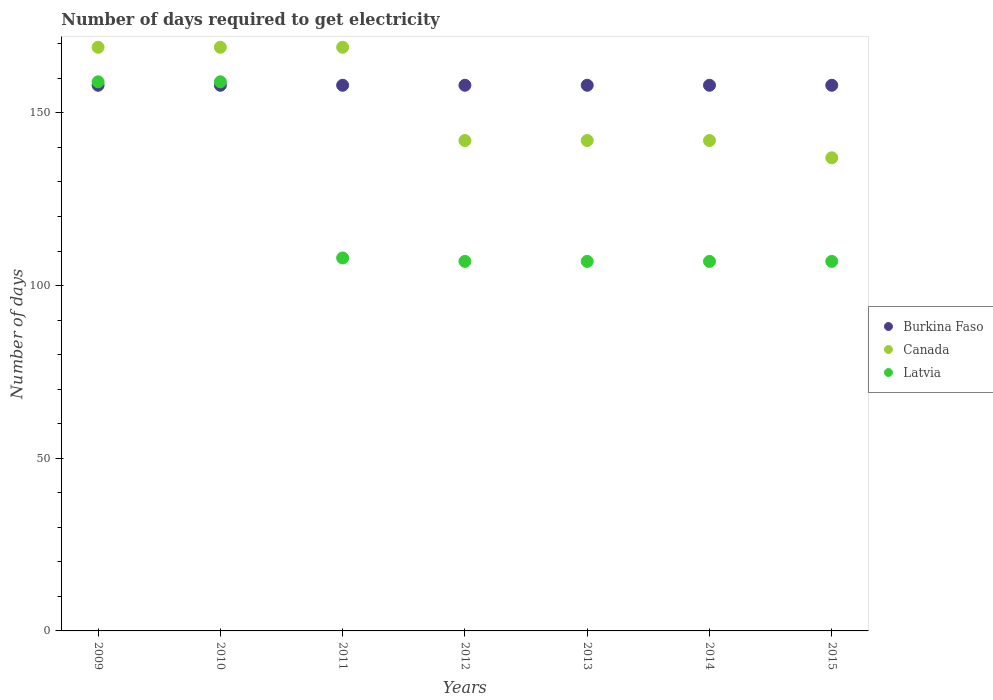How many different coloured dotlines are there?
Offer a terse response. 3. Is the number of dotlines equal to the number of legend labels?
Offer a terse response. Yes. What is the number of days required to get electricity in in Canada in 2013?
Your answer should be very brief. 142. Across all years, what is the maximum number of days required to get electricity in in Canada?
Your answer should be compact. 169. Across all years, what is the minimum number of days required to get electricity in in Burkina Faso?
Offer a terse response. 158. In which year was the number of days required to get electricity in in Burkina Faso maximum?
Give a very brief answer. 2009. In which year was the number of days required to get electricity in in Canada minimum?
Keep it short and to the point. 2015. What is the total number of days required to get electricity in in Burkina Faso in the graph?
Offer a very short reply. 1106. What is the difference between the number of days required to get electricity in in Canada in 2010 and that in 2015?
Offer a very short reply. 32. What is the difference between the number of days required to get electricity in in Burkina Faso in 2009 and the number of days required to get electricity in in Latvia in 2012?
Make the answer very short. 51. What is the average number of days required to get electricity in in Burkina Faso per year?
Your answer should be very brief. 158. In the year 2013, what is the difference between the number of days required to get electricity in in Latvia and number of days required to get electricity in in Canada?
Your answer should be very brief. -35. In how many years, is the number of days required to get electricity in in Burkina Faso greater than 100 days?
Make the answer very short. 7. Is the difference between the number of days required to get electricity in in Latvia in 2011 and 2015 greater than the difference between the number of days required to get electricity in in Canada in 2011 and 2015?
Ensure brevity in your answer.  No. What is the difference between the highest and the lowest number of days required to get electricity in in Burkina Faso?
Provide a succinct answer. 0. In how many years, is the number of days required to get electricity in in Canada greater than the average number of days required to get electricity in in Canada taken over all years?
Offer a terse response. 3. Is the sum of the number of days required to get electricity in in Burkina Faso in 2009 and 2013 greater than the maximum number of days required to get electricity in in Canada across all years?
Keep it short and to the point. Yes. Is the number of days required to get electricity in in Burkina Faso strictly less than the number of days required to get electricity in in Latvia over the years?
Your answer should be compact. No. How many dotlines are there?
Keep it short and to the point. 3. What is the difference between two consecutive major ticks on the Y-axis?
Make the answer very short. 50. Does the graph contain any zero values?
Offer a terse response. No. What is the title of the graph?
Ensure brevity in your answer.  Number of days required to get electricity. What is the label or title of the Y-axis?
Make the answer very short. Number of days. What is the Number of days of Burkina Faso in 2009?
Your response must be concise. 158. What is the Number of days of Canada in 2009?
Give a very brief answer. 169. What is the Number of days of Latvia in 2009?
Ensure brevity in your answer.  159. What is the Number of days of Burkina Faso in 2010?
Offer a terse response. 158. What is the Number of days of Canada in 2010?
Provide a succinct answer. 169. What is the Number of days of Latvia in 2010?
Your response must be concise. 159. What is the Number of days in Burkina Faso in 2011?
Ensure brevity in your answer.  158. What is the Number of days of Canada in 2011?
Provide a short and direct response. 169. What is the Number of days in Latvia in 2011?
Your answer should be very brief. 108. What is the Number of days of Burkina Faso in 2012?
Give a very brief answer. 158. What is the Number of days in Canada in 2012?
Your answer should be compact. 142. What is the Number of days of Latvia in 2012?
Your answer should be compact. 107. What is the Number of days in Burkina Faso in 2013?
Provide a succinct answer. 158. What is the Number of days in Canada in 2013?
Offer a very short reply. 142. What is the Number of days in Latvia in 2013?
Offer a very short reply. 107. What is the Number of days of Burkina Faso in 2014?
Your answer should be very brief. 158. What is the Number of days in Canada in 2014?
Ensure brevity in your answer.  142. What is the Number of days in Latvia in 2014?
Give a very brief answer. 107. What is the Number of days in Burkina Faso in 2015?
Your answer should be very brief. 158. What is the Number of days in Canada in 2015?
Give a very brief answer. 137. What is the Number of days of Latvia in 2015?
Offer a terse response. 107. Across all years, what is the maximum Number of days of Burkina Faso?
Give a very brief answer. 158. Across all years, what is the maximum Number of days of Canada?
Provide a short and direct response. 169. Across all years, what is the maximum Number of days in Latvia?
Make the answer very short. 159. Across all years, what is the minimum Number of days in Burkina Faso?
Your response must be concise. 158. Across all years, what is the minimum Number of days of Canada?
Give a very brief answer. 137. Across all years, what is the minimum Number of days of Latvia?
Provide a short and direct response. 107. What is the total Number of days of Burkina Faso in the graph?
Offer a terse response. 1106. What is the total Number of days of Canada in the graph?
Keep it short and to the point. 1070. What is the total Number of days of Latvia in the graph?
Offer a very short reply. 854. What is the difference between the Number of days in Burkina Faso in 2009 and that in 2010?
Your response must be concise. 0. What is the difference between the Number of days in Latvia in 2009 and that in 2010?
Keep it short and to the point. 0. What is the difference between the Number of days of Burkina Faso in 2009 and that in 2011?
Give a very brief answer. 0. What is the difference between the Number of days of Burkina Faso in 2009 and that in 2013?
Ensure brevity in your answer.  0. What is the difference between the Number of days of Latvia in 2009 and that in 2013?
Provide a succinct answer. 52. What is the difference between the Number of days in Burkina Faso in 2009 and that in 2014?
Give a very brief answer. 0. What is the difference between the Number of days of Burkina Faso in 2009 and that in 2015?
Your answer should be compact. 0. What is the difference between the Number of days of Canada in 2009 and that in 2015?
Offer a very short reply. 32. What is the difference between the Number of days of Burkina Faso in 2010 and that in 2011?
Your answer should be very brief. 0. What is the difference between the Number of days of Canada in 2010 and that in 2011?
Make the answer very short. 0. What is the difference between the Number of days in Burkina Faso in 2010 and that in 2012?
Provide a short and direct response. 0. What is the difference between the Number of days in Canada in 2010 and that in 2012?
Your response must be concise. 27. What is the difference between the Number of days of Latvia in 2010 and that in 2012?
Offer a terse response. 52. What is the difference between the Number of days in Burkina Faso in 2010 and that in 2013?
Your response must be concise. 0. What is the difference between the Number of days in Canada in 2010 and that in 2013?
Offer a terse response. 27. What is the difference between the Number of days of Burkina Faso in 2010 and that in 2014?
Offer a very short reply. 0. What is the difference between the Number of days of Canada in 2010 and that in 2014?
Keep it short and to the point. 27. What is the difference between the Number of days of Burkina Faso in 2010 and that in 2015?
Keep it short and to the point. 0. What is the difference between the Number of days of Canada in 2010 and that in 2015?
Give a very brief answer. 32. What is the difference between the Number of days in Canada in 2011 and that in 2012?
Your response must be concise. 27. What is the difference between the Number of days in Canada in 2011 and that in 2013?
Your answer should be compact. 27. What is the difference between the Number of days of Latvia in 2011 and that in 2013?
Provide a succinct answer. 1. What is the difference between the Number of days of Burkina Faso in 2011 and that in 2014?
Give a very brief answer. 0. What is the difference between the Number of days in Canada in 2011 and that in 2014?
Your response must be concise. 27. What is the difference between the Number of days in Latvia in 2011 and that in 2014?
Offer a terse response. 1. What is the difference between the Number of days in Burkina Faso in 2011 and that in 2015?
Offer a terse response. 0. What is the difference between the Number of days in Canada in 2011 and that in 2015?
Keep it short and to the point. 32. What is the difference between the Number of days in Burkina Faso in 2012 and that in 2013?
Ensure brevity in your answer.  0. What is the difference between the Number of days in Burkina Faso in 2012 and that in 2014?
Provide a succinct answer. 0. What is the difference between the Number of days in Latvia in 2012 and that in 2014?
Give a very brief answer. 0. What is the difference between the Number of days of Burkina Faso in 2012 and that in 2015?
Your answer should be compact. 0. What is the difference between the Number of days of Canada in 2012 and that in 2015?
Your answer should be very brief. 5. What is the difference between the Number of days of Burkina Faso in 2013 and that in 2014?
Give a very brief answer. 0. What is the difference between the Number of days of Canada in 2013 and that in 2014?
Provide a succinct answer. 0. What is the difference between the Number of days in Canada in 2013 and that in 2015?
Provide a short and direct response. 5. What is the difference between the Number of days of Latvia in 2013 and that in 2015?
Offer a terse response. 0. What is the difference between the Number of days of Burkina Faso in 2009 and the Number of days of Canada in 2010?
Provide a short and direct response. -11. What is the difference between the Number of days of Burkina Faso in 2009 and the Number of days of Canada in 2011?
Offer a terse response. -11. What is the difference between the Number of days in Burkina Faso in 2009 and the Number of days in Latvia in 2012?
Ensure brevity in your answer.  51. What is the difference between the Number of days of Burkina Faso in 2009 and the Number of days of Canada in 2013?
Your answer should be very brief. 16. What is the difference between the Number of days in Burkina Faso in 2009 and the Number of days in Latvia in 2013?
Keep it short and to the point. 51. What is the difference between the Number of days of Canada in 2009 and the Number of days of Latvia in 2015?
Provide a succinct answer. 62. What is the difference between the Number of days of Burkina Faso in 2010 and the Number of days of Latvia in 2011?
Provide a short and direct response. 50. What is the difference between the Number of days of Canada in 2010 and the Number of days of Latvia in 2011?
Your answer should be compact. 61. What is the difference between the Number of days of Burkina Faso in 2010 and the Number of days of Latvia in 2012?
Provide a short and direct response. 51. What is the difference between the Number of days of Canada in 2010 and the Number of days of Latvia in 2012?
Provide a succinct answer. 62. What is the difference between the Number of days of Burkina Faso in 2010 and the Number of days of Canada in 2013?
Ensure brevity in your answer.  16. What is the difference between the Number of days in Canada in 2010 and the Number of days in Latvia in 2013?
Keep it short and to the point. 62. What is the difference between the Number of days in Burkina Faso in 2010 and the Number of days in Canada in 2014?
Offer a terse response. 16. What is the difference between the Number of days in Burkina Faso in 2010 and the Number of days in Canada in 2015?
Provide a short and direct response. 21. What is the difference between the Number of days of Burkina Faso in 2011 and the Number of days of Latvia in 2012?
Make the answer very short. 51. What is the difference between the Number of days in Canada in 2011 and the Number of days in Latvia in 2012?
Offer a terse response. 62. What is the difference between the Number of days in Canada in 2011 and the Number of days in Latvia in 2014?
Provide a short and direct response. 62. What is the difference between the Number of days in Burkina Faso in 2011 and the Number of days in Canada in 2015?
Give a very brief answer. 21. What is the difference between the Number of days in Canada in 2012 and the Number of days in Latvia in 2013?
Give a very brief answer. 35. What is the difference between the Number of days of Burkina Faso in 2012 and the Number of days of Canada in 2014?
Your answer should be compact. 16. What is the difference between the Number of days in Burkina Faso in 2012 and the Number of days in Canada in 2015?
Make the answer very short. 21. What is the difference between the Number of days of Burkina Faso in 2012 and the Number of days of Latvia in 2015?
Your response must be concise. 51. What is the difference between the Number of days of Burkina Faso in 2013 and the Number of days of Canada in 2014?
Your answer should be very brief. 16. What is the difference between the Number of days in Burkina Faso in 2013 and the Number of days in Canada in 2015?
Your answer should be very brief. 21. What is the difference between the Number of days in Burkina Faso in 2013 and the Number of days in Latvia in 2015?
Ensure brevity in your answer.  51. What is the difference between the Number of days in Canada in 2013 and the Number of days in Latvia in 2015?
Provide a short and direct response. 35. What is the difference between the Number of days of Burkina Faso in 2014 and the Number of days of Latvia in 2015?
Your answer should be compact. 51. What is the difference between the Number of days of Canada in 2014 and the Number of days of Latvia in 2015?
Your answer should be compact. 35. What is the average Number of days in Burkina Faso per year?
Your response must be concise. 158. What is the average Number of days of Canada per year?
Offer a very short reply. 152.86. What is the average Number of days of Latvia per year?
Make the answer very short. 122. In the year 2010, what is the difference between the Number of days of Burkina Faso and Number of days of Latvia?
Your response must be concise. -1. In the year 2010, what is the difference between the Number of days in Canada and Number of days in Latvia?
Give a very brief answer. 10. In the year 2011, what is the difference between the Number of days of Canada and Number of days of Latvia?
Provide a succinct answer. 61. In the year 2013, what is the difference between the Number of days in Burkina Faso and Number of days in Canada?
Provide a succinct answer. 16. In the year 2013, what is the difference between the Number of days of Burkina Faso and Number of days of Latvia?
Your answer should be very brief. 51. In the year 2013, what is the difference between the Number of days in Canada and Number of days in Latvia?
Keep it short and to the point. 35. In the year 2014, what is the difference between the Number of days in Burkina Faso and Number of days in Canada?
Keep it short and to the point. 16. What is the ratio of the Number of days of Burkina Faso in 2009 to that in 2010?
Offer a terse response. 1. What is the ratio of the Number of days in Latvia in 2009 to that in 2010?
Provide a short and direct response. 1. What is the ratio of the Number of days of Latvia in 2009 to that in 2011?
Your answer should be very brief. 1.47. What is the ratio of the Number of days in Burkina Faso in 2009 to that in 2012?
Make the answer very short. 1. What is the ratio of the Number of days in Canada in 2009 to that in 2012?
Your answer should be compact. 1.19. What is the ratio of the Number of days of Latvia in 2009 to that in 2012?
Your response must be concise. 1.49. What is the ratio of the Number of days of Burkina Faso in 2009 to that in 2013?
Offer a very short reply. 1. What is the ratio of the Number of days in Canada in 2009 to that in 2013?
Keep it short and to the point. 1.19. What is the ratio of the Number of days in Latvia in 2009 to that in 2013?
Ensure brevity in your answer.  1.49. What is the ratio of the Number of days in Canada in 2009 to that in 2014?
Your answer should be very brief. 1.19. What is the ratio of the Number of days in Latvia in 2009 to that in 2014?
Give a very brief answer. 1.49. What is the ratio of the Number of days in Burkina Faso in 2009 to that in 2015?
Your answer should be compact. 1. What is the ratio of the Number of days in Canada in 2009 to that in 2015?
Offer a terse response. 1.23. What is the ratio of the Number of days in Latvia in 2009 to that in 2015?
Offer a very short reply. 1.49. What is the ratio of the Number of days in Burkina Faso in 2010 to that in 2011?
Offer a very short reply. 1. What is the ratio of the Number of days of Latvia in 2010 to that in 2011?
Provide a succinct answer. 1.47. What is the ratio of the Number of days of Burkina Faso in 2010 to that in 2012?
Your answer should be compact. 1. What is the ratio of the Number of days of Canada in 2010 to that in 2012?
Ensure brevity in your answer.  1.19. What is the ratio of the Number of days in Latvia in 2010 to that in 2012?
Offer a terse response. 1.49. What is the ratio of the Number of days in Canada in 2010 to that in 2013?
Ensure brevity in your answer.  1.19. What is the ratio of the Number of days in Latvia in 2010 to that in 2013?
Give a very brief answer. 1.49. What is the ratio of the Number of days of Burkina Faso in 2010 to that in 2014?
Offer a very short reply. 1. What is the ratio of the Number of days in Canada in 2010 to that in 2014?
Ensure brevity in your answer.  1.19. What is the ratio of the Number of days in Latvia in 2010 to that in 2014?
Offer a terse response. 1.49. What is the ratio of the Number of days of Burkina Faso in 2010 to that in 2015?
Your answer should be very brief. 1. What is the ratio of the Number of days in Canada in 2010 to that in 2015?
Offer a terse response. 1.23. What is the ratio of the Number of days of Latvia in 2010 to that in 2015?
Offer a very short reply. 1.49. What is the ratio of the Number of days of Canada in 2011 to that in 2012?
Make the answer very short. 1.19. What is the ratio of the Number of days of Latvia in 2011 to that in 2012?
Make the answer very short. 1.01. What is the ratio of the Number of days in Burkina Faso in 2011 to that in 2013?
Offer a very short reply. 1. What is the ratio of the Number of days in Canada in 2011 to that in 2013?
Give a very brief answer. 1.19. What is the ratio of the Number of days of Latvia in 2011 to that in 2013?
Your answer should be compact. 1.01. What is the ratio of the Number of days in Burkina Faso in 2011 to that in 2014?
Make the answer very short. 1. What is the ratio of the Number of days of Canada in 2011 to that in 2014?
Give a very brief answer. 1.19. What is the ratio of the Number of days of Latvia in 2011 to that in 2014?
Your answer should be very brief. 1.01. What is the ratio of the Number of days of Canada in 2011 to that in 2015?
Offer a terse response. 1.23. What is the ratio of the Number of days of Latvia in 2011 to that in 2015?
Make the answer very short. 1.01. What is the ratio of the Number of days of Burkina Faso in 2012 to that in 2013?
Keep it short and to the point. 1. What is the ratio of the Number of days in Burkina Faso in 2012 to that in 2014?
Offer a very short reply. 1. What is the ratio of the Number of days in Burkina Faso in 2012 to that in 2015?
Your response must be concise. 1. What is the ratio of the Number of days in Canada in 2012 to that in 2015?
Your answer should be very brief. 1.04. What is the ratio of the Number of days of Canada in 2013 to that in 2014?
Offer a very short reply. 1. What is the ratio of the Number of days of Latvia in 2013 to that in 2014?
Ensure brevity in your answer.  1. What is the ratio of the Number of days in Canada in 2013 to that in 2015?
Make the answer very short. 1.04. What is the ratio of the Number of days of Latvia in 2013 to that in 2015?
Your answer should be very brief. 1. What is the ratio of the Number of days of Canada in 2014 to that in 2015?
Give a very brief answer. 1.04. What is the ratio of the Number of days in Latvia in 2014 to that in 2015?
Ensure brevity in your answer.  1. What is the difference between the highest and the lowest Number of days in Canada?
Your answer should be compact. 32. What is the difference between the highest and the lowest Number of days in Latvia?
Your answer should be compact. 52. 